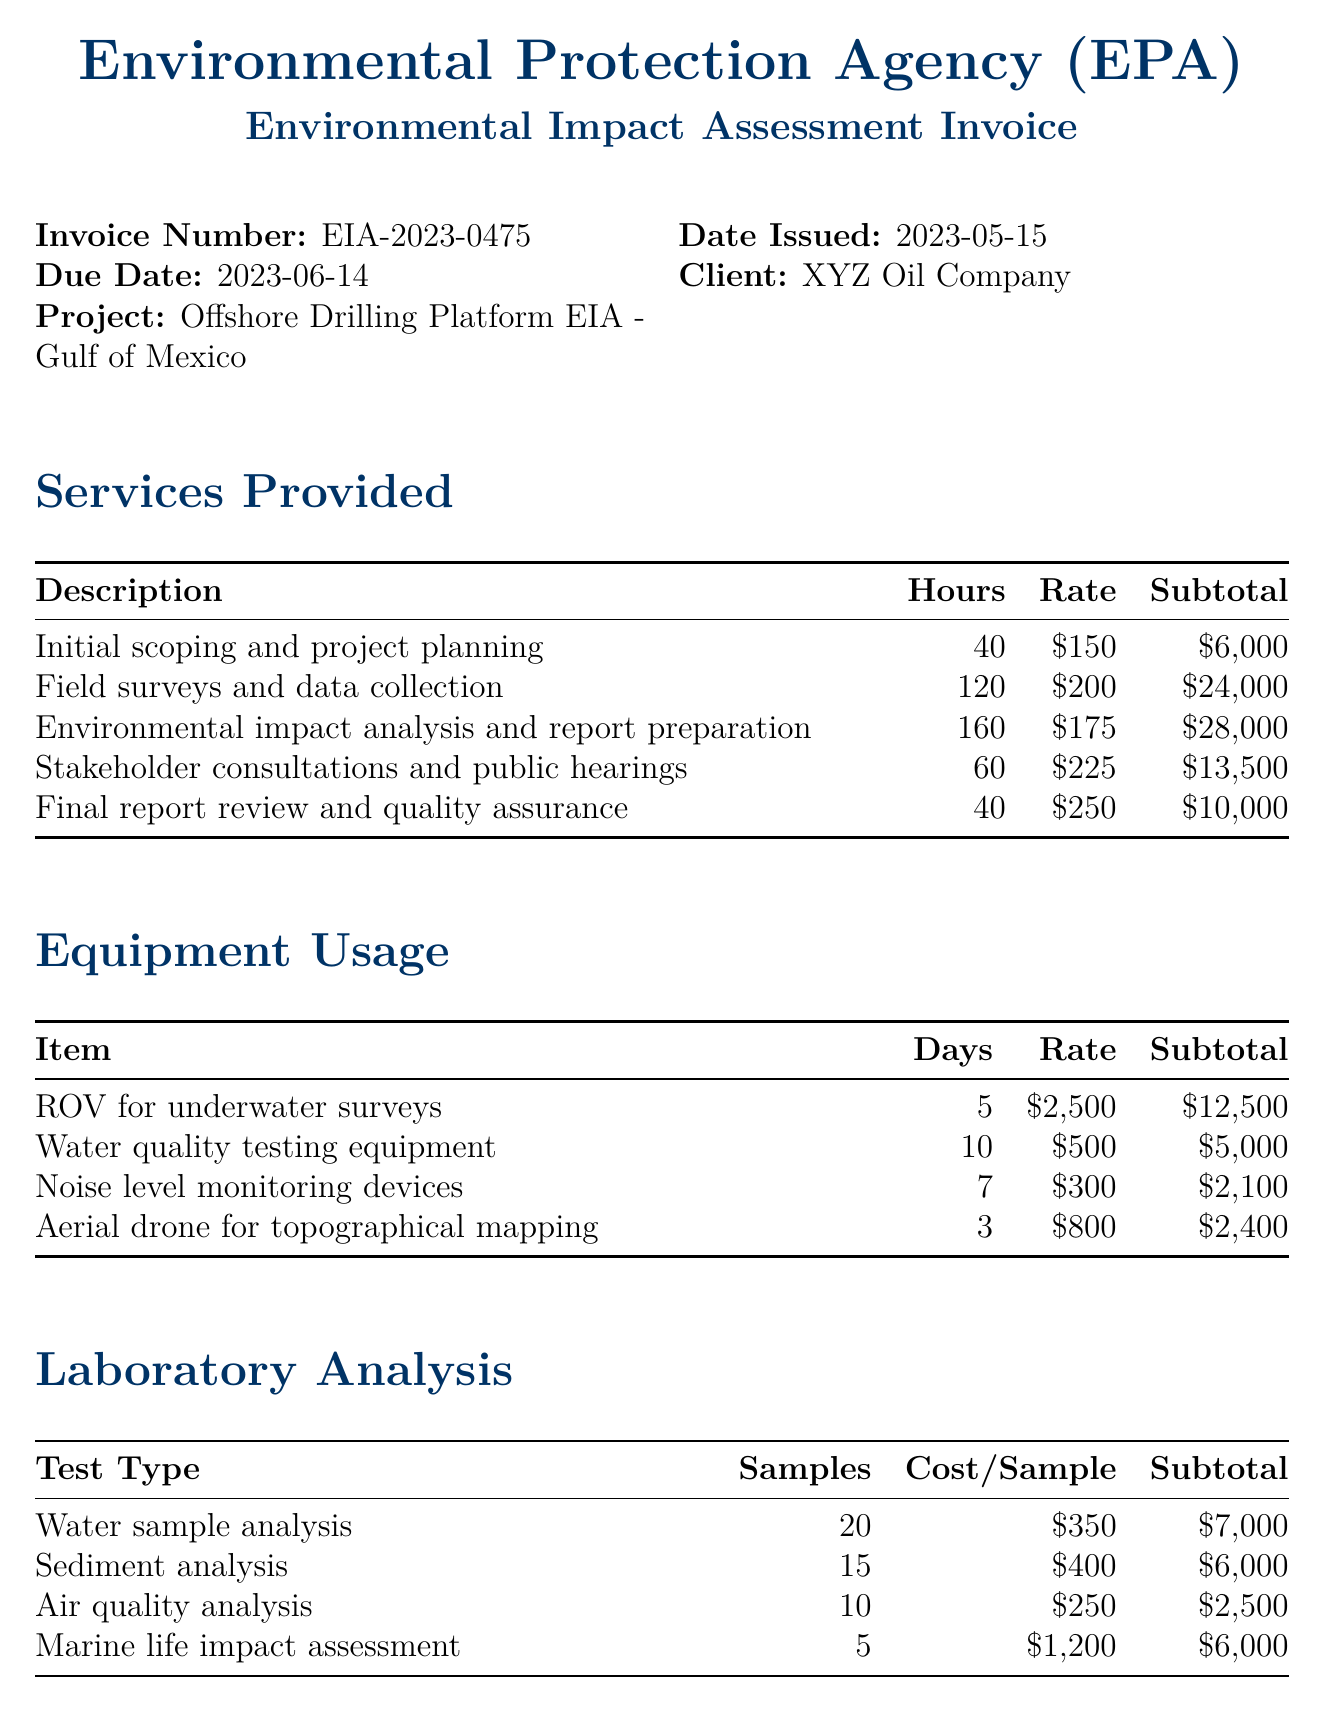what is the invoice number? The invoice number is a unique identifier for the transaction, indicated in the document.
Answer: EIA-2023-0475 what is the total amount due? The total amount due is indicated at the bottom of the invoice as the grand total.
Answer: 155000 how many hours were spent on environmental impact analysis and report preparation? This information is provided in the detailed breakdown of services rendered in the document.
Answer: 160 what is the cost per sample for water sample analysis? The cost per sample for each type of analysis is specified in the laboratory analysis section.
Answer: 350 how many days was the ROV used for surveys? The number of days an equipment was used is detailed in the equipment usage section of the document.
Answer: 5 what was the subtotal for stakeholder consultations and public hearings? The subtotal is calculated based on the rate and man-hours for each service in the services provided section.
Answer: 13500 what is the payment method stated in the document? The payment method is specified in the payment terms section of the invoice.
Answer: Bank transfer which authority issued the invoice? The issuing authority is mentioned at the top of the invoice document.
Answer: Environmental Protection Agency (EPA) what is the number of samples analyzed for air quality? The number of samples for different tests is detailed in the laboratory analysis section.
Answer: 10 